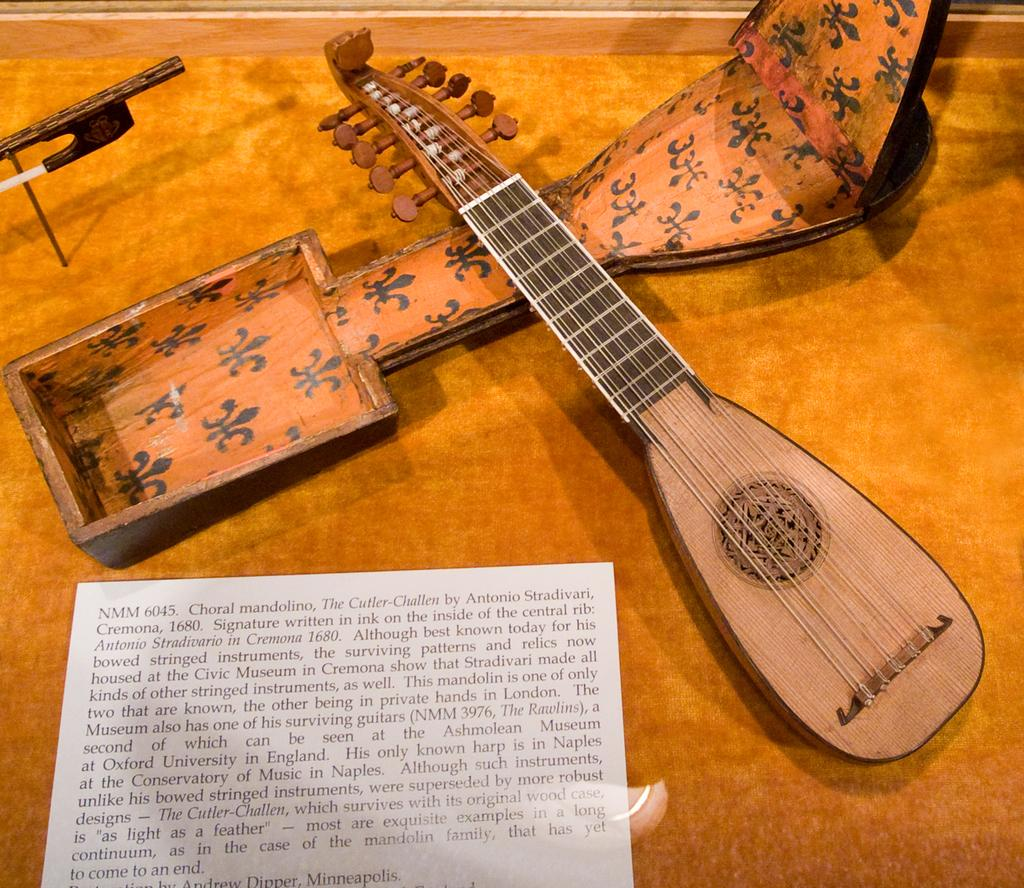What is present in the image that can be written on or read? There is a paper in the image. What musical instrument can be seen in the image? There is a mandolin in the image. Where is the mandolin's cover located in the image? The mandolin's cover is on the floor in the image. How many children are playing with the mandolin in the image? There are no children present in the image, and the mandolin is not being played with. How many legs does the mandolin have in the image? The mandolin is a musical instrument and does not have legs; it has strings and a body. 